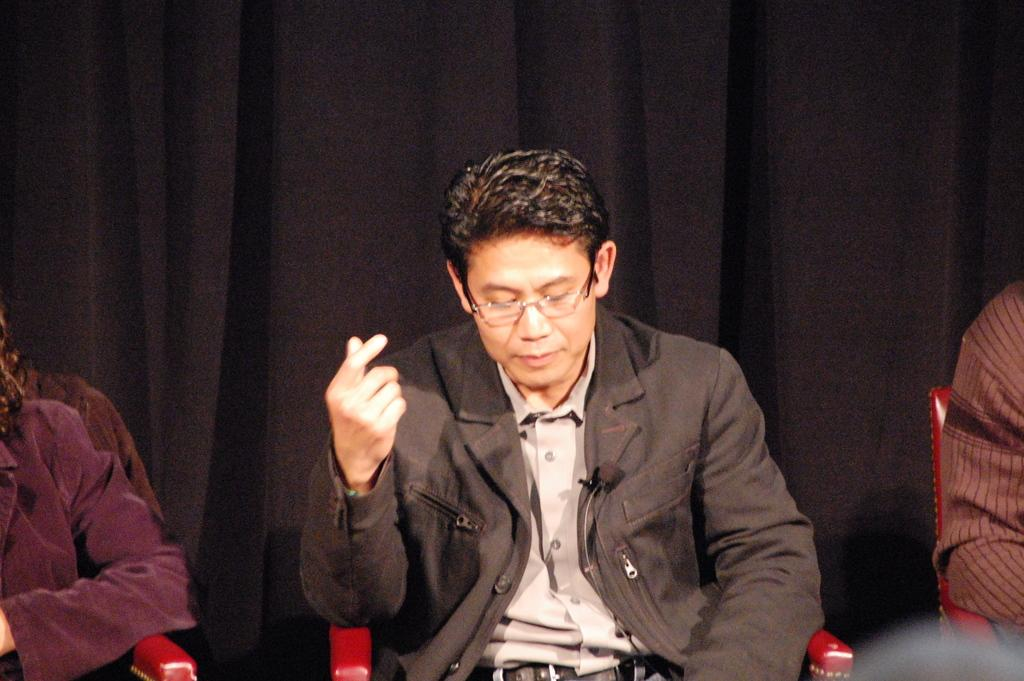Who or what is present in the image? There are people in the image. What are the people doing in the image? The people are sitting on chairs. What can be seen in the background of the image? There is a curtain in the background of the image. What holiday is being celebrated in the image? There is no indication of a holiday being celebrated in the image. How many people are touching the curtain in the image? There are no people touching the curtain in the image. 